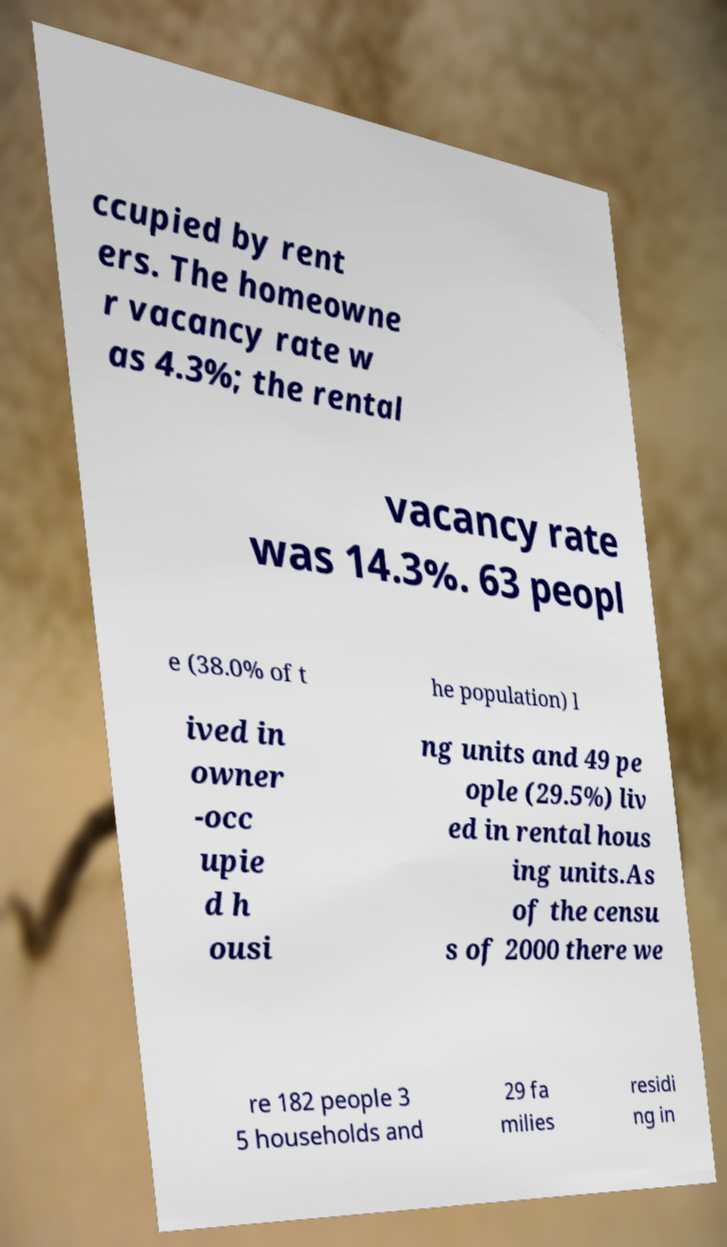For documentation purposes, I need the text within this image transcribed. Could you provide that? ccupied by rent ers. The homeowne r vacancy rate w as 4.3%; the rental vacancy rate was 14.3%. 63 peopl e (38.0% of t he population) l ived in owner -occ upie d h ousi ng units and 49 pe ople (29.5%) liv ed in rental hous ing units.As of the censu s of 2000 there we re 182 people 3 5 households and 29 fa milies residi ng in 